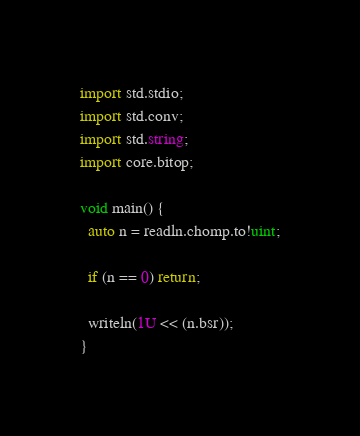<code> <loc_0><loc_0><loc_500><loc_500><_D_>import std.stdio;
import std.conv;
import std.string;
import core.bitop;

void main() {
  auto n = readln.chomp.to!uint;

  if (n == 0) return;

  writeln(1U << (n.bsr));
}
</code> 